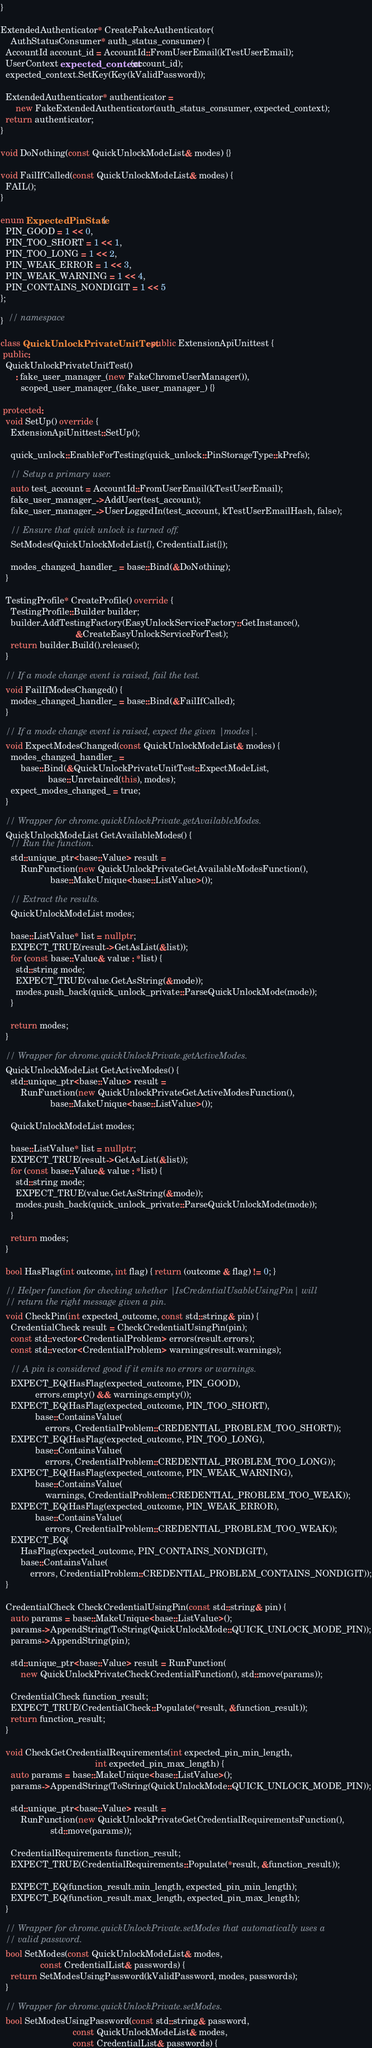Convert code to text. <code><loc_0><loc_0><loc_500><loc_500><_C++_>}

ExtendedAuthenticator* CreateFakeAuthenticator(
    AuthStatusConsumer* auth_status_consumer) {
  AccountId account_id = AccountId::FromUserEmail(kTestUserEmail);
  UserContext expected_context(account_id);
  expected_context.SetKey(Key(kValidPassword));

  ExtendedAuthenticator* authenticator =
      new FakeExtendedAuthenticator(auth_status_consumer, expected_context);
  return authenticator;
}

void DoNothing(const QuickUnlockModeList& modes) {}

void FailIfCalled(const QuickUnlockModeList& modes) {
  FAIL();
}

enum ExpectedPinState {
  PIN_GOOD = 1 << 0,
  PIN_TOO_SHORT = 1 << 1,
  PIN_TOO_LONG = 1 << 2,
  PIN_WEAK_ERROR = 1 << 3,
  PIN_WEAK_WARNING = 1 << 4,
  PIN_CONTAINS_NONDIGIT = 1 << 5
};

}  // namespace

class QuickUnlockPrivateUnitTest : public ExtensionApiUnittest {
 public:
  QuickUnlockPrivateUnitTest()
      : fake_user_manager_(new FakeChromeUserManager()),
        scoped_user_manager_(fake_user_manager_) {}

 protected:
  void SetUp() override {
    ExtensionApiUnittest::SetUp();

    quick_unlock::EnableForTesting(quick_unlock::PinStorageType::kPrefs);

    // Setup a primary user.
    auto test_account = AccountId::FromUserEmail(kTestUserEmail);
    fake_user_manager_->AddUser(test_account);
    fake_user_manager_->UserLoggedIn(test_account, kTestUserEmailHash, false);

    // Ensure that quick unlock is turned off.
    SetModes(QuickUnlockModeList{}, CredentialList{});

    modes_changed_handler_ = base::Bind(&DoNothing);
  }

  TestingProfile* CreateProfile() override {
    TestingProfile::Builder builder;
    builder.AddTestingFactory(EasyUnlockServiceFactory::GetInstance(),
                              &CreateEasyUnlockServiceForTest);
    return builder.Build().release();
  }

  // If a mode change event is raised, fail the test.
  void FailIfModesChanged() {
    modes_changed_handler_ = base::Bind(&FailIfCalled);
  }

  // If a mode change event is raised, expect the given |modes|.
  void ExpectModesChanged(const QuickUnlockModeList& modes) {
    modes_changed_handler_ =
        base::Bind(&QuickUnlockPrivateUnitTest::ExpectModeList,
                   base::Unretained(this), modes);
    expect_modes_changed_ = true;
  }

  // Wrapper for chrome.quickUnlockPrivate.getAvailableModes.
  QuickUnlockModeList GetAvailableModes() {
    // Run the function.
    std::unique_ptr<base::Value> result =
        RunFunction(new QuickUnlockPrivateGetAvailableModesFunction(),
                    base::MakeUnique<base::ListValue>());

    // Extract the results.
    QuickUnlockModeList modes;

    base::ListValue* list = nullptr;
    EXPECT_TRUE(result->GetAsList(&list));
    for (const base::Value& value : *list) {
      std::string mode;
      EXPECT_TRUE(value.GetAsString(&mode));
      modes.push_back(quick_unlock_private::ParseQuickUnlockMode(mode));
    }

    return modes;
  }

  // Wrapper for chrome.quickUnlockPrivate.getActiveModes.
  QuickUnlockModeList GetActiveModes() {
    std::unique_ptr<base::Value> result =
        RunFunction(new QuickUnlockPrivateGetActiveModesFunction(),
                    base::MakeUnique<base::ListValue>());

    QuickUnlockModeList modes;

    base::ListValue* list = nullptr;
    EXPECT_TRUE(result->GetAsList(&list));
    for (const base::Value& value : *list) {
      std::string mode;
      EXPECT_TRUE(value.GetAsString(&mode));
      modes.push_back(quick_unlock_private::ParseQuickUnlockMode(mode));
    }

    return modes;
  }

  bool HasFlag(int outcome, int flag) { return (outcome & flag) != 0; }

  // Helper function for checking whether |IsCredentialUsableUsingPin| will
  // return the right message given a pin.
  void CheckPin(int expected_outcome, const std::string& pin) {
    CredentialCheck result = CheckCredentialUsingPin(pin);
    const std::vector<CredentialProblem> errors(result.errors);
    const std::vector<CredentialProblem> warnings(result.warnings);

    // A pin is considered good if it emits no errors or warnings.
    EXPECT_EQ(HasFlag(expected_outcome, PIN_GOOD),
              errors.empty() && warnings.empty());
    EXPECT_EQ(HasFlag(expected_outcome, PIN_TOO_SHORT),
              base::ContainsValue(
                  errors, CredentialProblem::CREDENTIAL_PROBLEM_TOO_SHORT));
    EXPECT_EQ(HasFlag(expected_outcome, PIN_TOO_LONG),
              base::ContainsValue(
                  errors, CredentialProblem::CREDENTIAL_PROBLEM_TOO_LONG));
    EXPECT_EQ(HasFlag(expected_outcome, PIN_WEAK_WARNING),
              base::ContainsValue(
                  warnings, CredentialProblem::CREDENTIAL_PROBLEM_TOO_WEAK));
    EXPECT_EQ(HasFlag(expected_outcome, PIN_WEAK_ERROR),
              base::ContainsValue(
                  errors, CredentialProblem::CREDENTIAL_PROBLEM_TOO_WEAK));
    EXPECT_EQ(
        HasFlag(expected_outcome, PIN_CONTAINS_NONDIGIT),
        base::ContainsValue(
            errors, CredentialProblem::CREDENTIAL_PROBLEM_CONTAINS_NONDIGIT));
  }

  CredentialCheck CheckCredentialUsingPin(const std::string& pin) {
    auto params = base::MakeUnique<base::ListValue>();
    params->AppendString(ToString(QuickUnlockMode::QUICK_UNLOCK_MODE_PIN));
    params->AppendString(pin);

    std::unique_ptr<base::Value> result = RunFunction(
        new QuickUnlockPrivateCheckCredentialFunction(), std::move(params));

    CredentialCheck function_result;
    EXPECT_TRUE(CredentialCheck::Populate(*result, &function_result));
    return function_result;
  }

  void CheckGetCredentialRequirements(int expected_pin_min_length,
                                      int expected_pin_max_length) {
    auto params = base::MakeUnique<base::ListValue>();
    params->AppendString(ToString(QuickUnlockMode::QUICK_UNLOCK_MODE_PIN));

    std::unique_ptr<base::Value> result =
        RunFunction(new QuickUnlockPrivateGetCredentialRequirementsFunction(),
                    std::move(params));

    CredentialRequirements function_result;
    EXPECT_TRUE(CredentialRequirements::Populate(*result, &function_result));

    EXPECT_EQ(function_result.min_length, expected_pin_min_length);
    EXPECT_EQ(function_result.max_length, expected_pin_max_length);
  }

  // Wrapper for chrome.quickUnlockPrivate.setModes that automatically uses a
  // valid password.
  bool SetModes(const QuickUnlockModeList& modes,
                const CredentialList& passwords) {
    return SetModesUsingPassword(kValidPassword, modes, passwords);
  }

  // Wrapper for chrome.quickUnlockPrivate.setModes.
  bool SetModesUsingPassword(const std::string& password,
                             const QuickUnlockModeList& modes,
                             const CredentialList& passwords) {</code> 